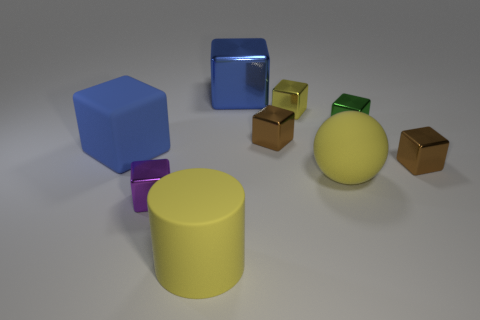The small object to the left of the big blue object to the right of the small purple cube is what color?
Keep it short and to the point. Purple. There is a big matte thing that is the same shape as the tiny yellow shiny object; what color is it?
Your answer should be compact. Blue. What size is the other blue thing that is the same shape as the large blue matte object?
Your answer should be very brief. Large. There is a large yellow object to the right of the cylinder; what is its material?
Offer a terse response. Rubber. Are there fewer big balls that are to the right of the green shiny object than small cyan matte cylinders?
Your answer should be very brief. No. There is a rubber thing that is on the left side of the metal object that is left of the large yellow cylinder; what shape is it?
Offer a very short reply. Cube. What color is the matte sphere?
Keep it short and to the point. Yellow. What number of other objects are the same size as the blue matte cube?
Keep it short and to the point. 3. What is the yellow object that is both right of the big rubber cylinder and in front of the matte cube made of?
Keep it short and to the point. Rubber. There is a blue thing on the left side of the purple shiny cube; is its size the same as the yellow rubber cylinder?
Your answer should be compact. Yes. 